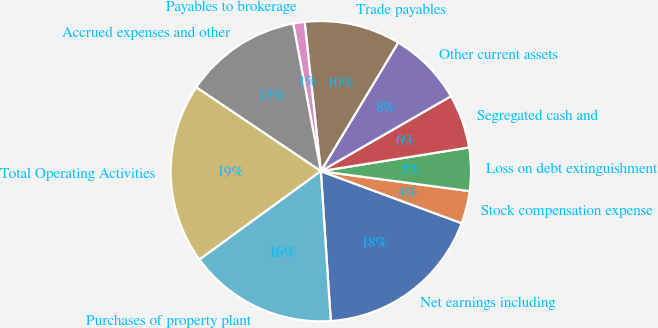Convert chart to OTSL. <chart><loc_0><loc_0><loc_500><loc_500><pie_chart><fcel>Net earnings including<fcel>Stock compensation expense<fcel>Loss on debt extinguishment<fcel>Segregated cash and<fcel>Other current assets<fcel>Trade payables<fcel>Payables to brokerage<fcel>Accrued expenses and other<fcel>Total Operating Activities<fcel>Purchases of property plant<nl><fcel>18.31%<fcel>3.51%<fcel>4.65%<fcel>5.79%<fcel>8.06%<fcel>10.34%<fcel>1.23%<fcel>12.62%<fcel>19.45%<fcel>16.04%<nl></chart> 